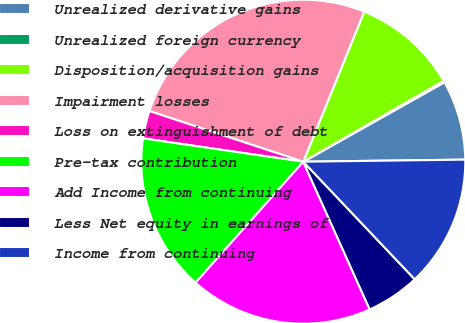Convert chart. <chart><loc_0><loc_0><loc_500><loc_500><pie_chart><fcel>Unrealized derivative gains<fcel>Unrealized foreign currency<fcel>Disposition/acquisition gains<fcel>Impairment losses<fcel>Loss on extinguishment of debt<fcel>Pre-tax contribution<fcel>Add Income from continuing<fcel>Less Net equity in earnings of<fcel>Income from continuing<nl><fcel>7.95%<fcel>0.17%<fcel>10.54%<fcel>26.08%<fcel>2.76%<fcel>15.72%<fcel>18.31%<fcel>5.35%<fcel>13.13%<nl></chart> 